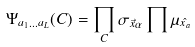<formula> <loc_0><loc_0><loc_500><loc_500>\Psi _ { a _ { 1 } \dots a _ { L } } ( C ) = \prod _ { C } \sigma _ { \vec { x } \alpha } \prod \mu _ { \hat { x _ { a } } }</formula> 